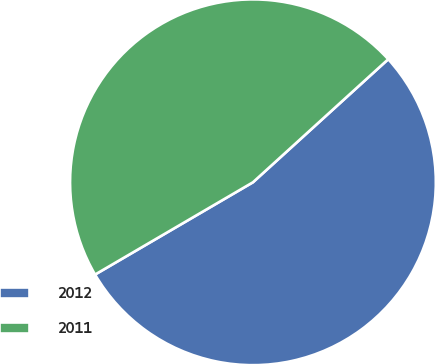<chart> <loc_0><loc_0><loc_500><loc_500><pie_chart><fcel>2012<fcel>2011<nl><fcel>53.33%<fcel>46.67%<nl></chart> 